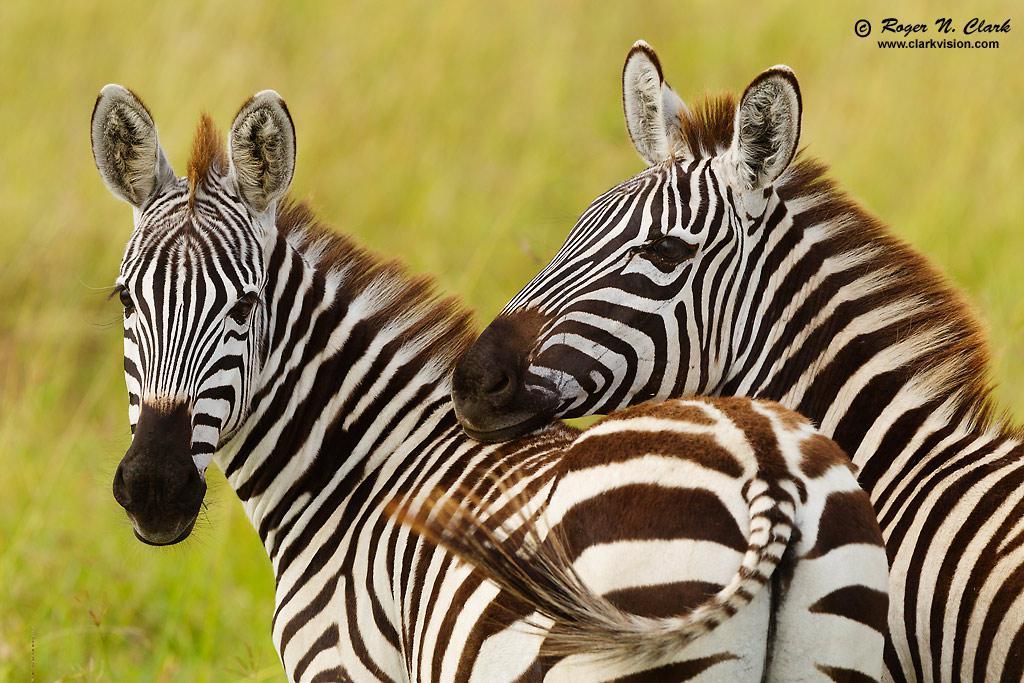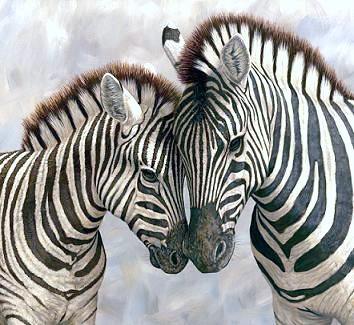The first image is the image on the left, the second image is the image on the right. Considering the images on both sides, is "In one image, one zebra has its head over the back of a zebra with its rear facing the camera and its neck turned so it can look forward." valid? Answer yes or no. Yes. 